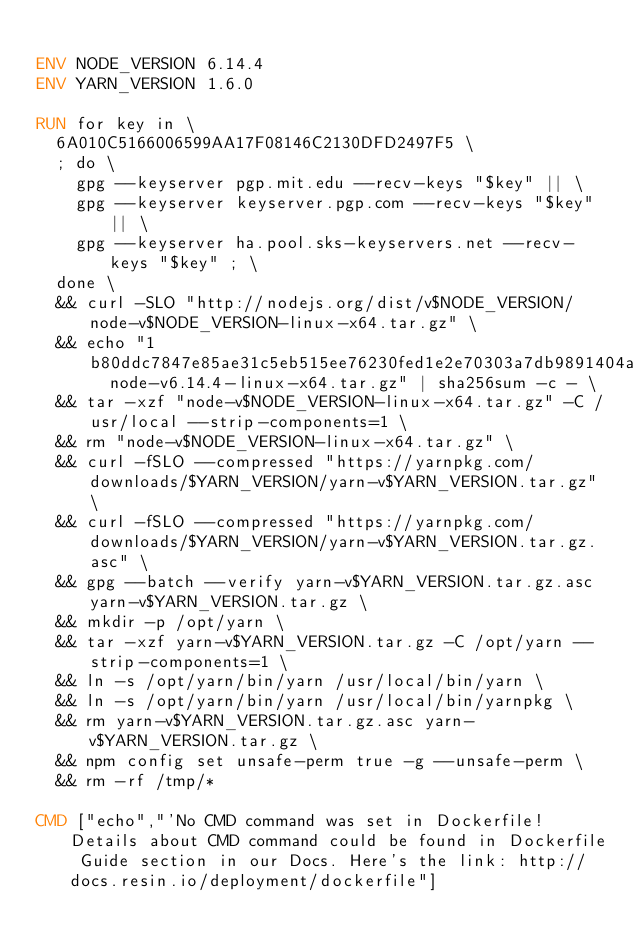Convert code to text. <code><loc_0><loc_0><loc_500><loc_500><_Dockerfile_>
ENV NODE_VERSION 6.14.4
ENV YARN_VERSION 1.6.0

RUN for key in \
	6A010C5166006599AA17F08146C2130DFD2497F5 \
	; do \
		gpg --keyserver pgp.mit.edu --recv-keys "$key" || \
		gpg --keyserver keyserver.pgp.com --recv-keys "$key" || \
		gpg --keyserver ha.pool.sks-keyservers.net --recv-keys "$key" ; \
	done \
	&& curl -SLO "http://nodejs.org/dist/v$NODE_VERSION/node-v$NODE_VERSION-linux-x64.tar.gz" \
	&& echo "1b80ddc7847e85ae31c5eb515ee76230fed1e2e70303a7db9891404a830128ba  node-v6.14.4-linux-x64.tar.gz" | sha256sum -c - \
	&& tar -xzf "node-v$NODE_VERSION-linux-x64.tar.gz" -C /usr/local --strip-components=1 \
	&& rm "node-v$NODE_VERSION-linux-x64.tar.gz" \
	&& curl -fSLO --compressed "https://yarnpkg.com/downloads/$YARN_VERSION/yarn-v$YARN_VERSION.tar.gz" \
	&& curl -fSLO --compressed "https://yarnpkg.com/downloads/$YARN_VERSION/yarn-v$YARN_VERSION.tar.gz.asc" \
	&& gpg --batch --verify yarn-v$YARN_VERSION.tar.gz.asc yarn-v$YARN_VERSION.tar.gz \
	&& mkdir -p /opt/yarn \
	&& tar -xzf yarn-v$YARN_VERSION.tar.gz -C /opt/yarn --strip-components=1 \
	&& ln -s /opt/yarn/bin/yarn /usr/local/bin/yarn \
	&& ln -s /opt/yarn/bin/yarn /usr/local/bin/yarnpkg \
	&& rm yarn-v$YARN_VERSION.tar.gz.asc yarn-v$YARN_VERSION.tar.gz \
	&& npm config set unsafe-perm true -g --unsafe-perm \
	&& rm -rf /tmp/*

CMD ["echo","'No CMD command was set in Dockerfile! Details about CMD command could be found in Dockerfile Guide section in our Docs. Here's the link: http://docs.resin.io/deployment/dockerfile"]
</code> 